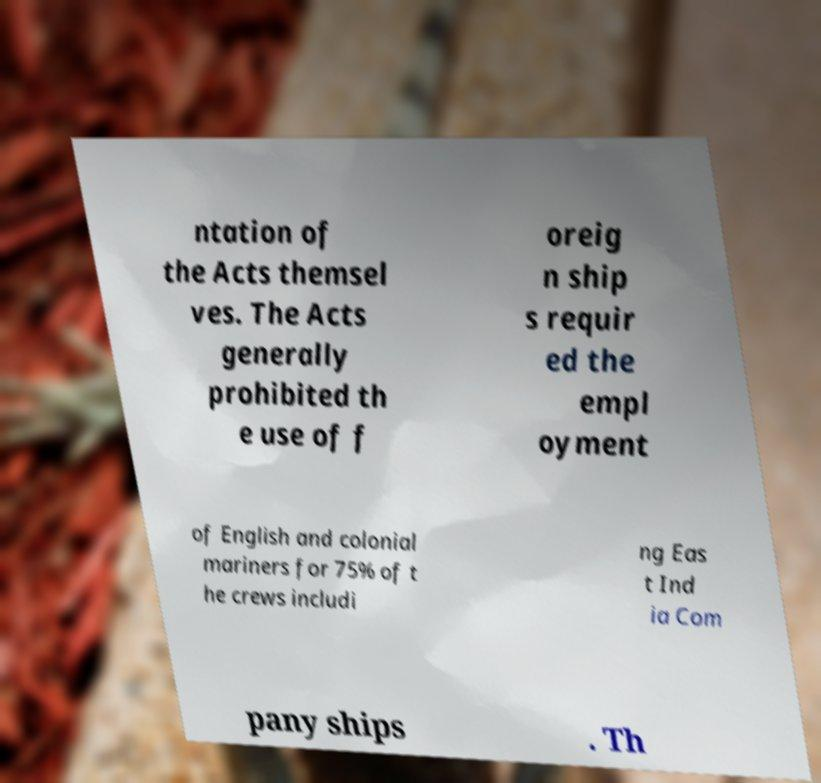Could you extract and type out the text from this image? ntation of the Acts themsel ves. The Acts generally prohibited th e use of f oreig n ship s requir ed the empl oyment of English and colonial mariners for 75% of t he crews includi ng Eas t Ind ia Com pany ships . Th 